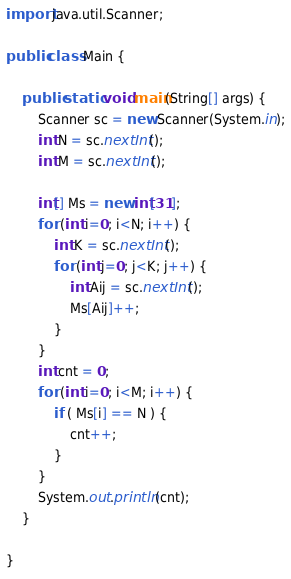Convert code to text. <code><loc_0><loc_0><loc_500><loc_500><_Java_>import java.util.Scanner;

public class Main {

	public static void main(String[] args) {
		Scanner sc = new Scanner(System.in);
		int N = sc.nextInt();
		int M = sc.nextInt();

		int[] Ms = new int[31];
		for (int i=0; i<N; i++) {
			int K = sc.nextInt();
			for (int j=0; j<K; j++) {
				int Aij = sc.nextInt();
				Ms[Aij]++;
			}
		}
		int cnt = 0;
		for (int i=0; i<M; i++) {
			if ( Ms[i] == N ) {
				cnt++;
			}
		}
		System.out.println(cnt);
	}

}
</code> 